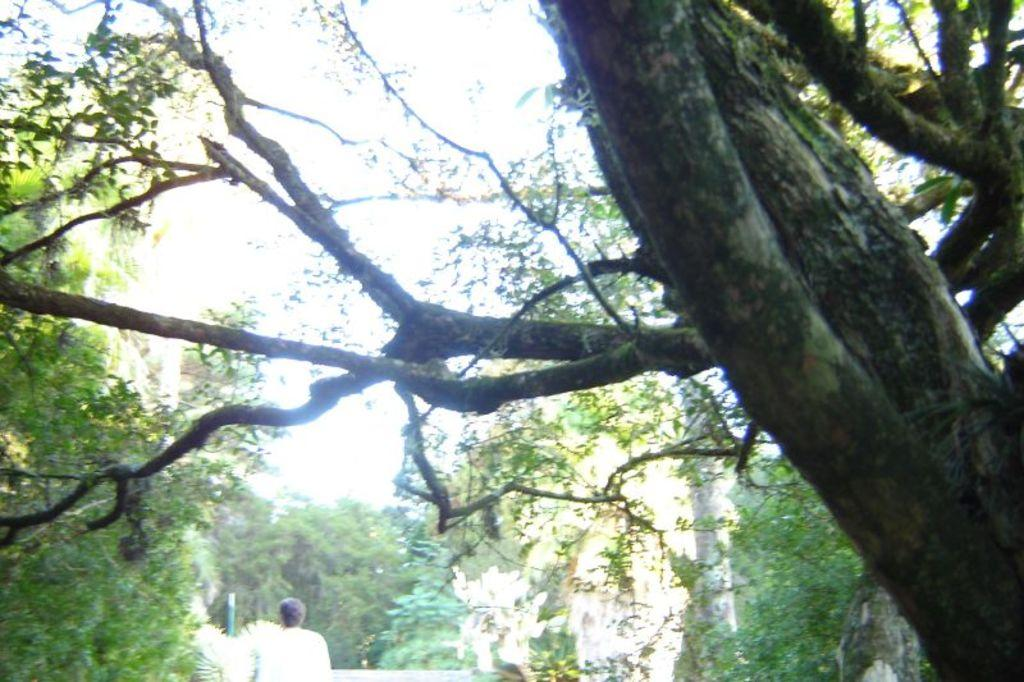What can be seen on the right side of the image? There is a tree trunk on the right side of the image. What is visible in the background of the image? There are trees in the background of the image. Can you describe the person at the bottom of the image? There is a person at the bottom of the image, but their appearance or actions are not specified. What color are the leaves on the left side of the image? The leaves on the left side of the image are green. Can you hear the goose honking in the image? There is no goose present in the image, so it is not possible to hear any honking. What type of agreement is being signed by the person in the image? There is no indication of a person signing an agreement or any agreement-related activity in the image. 